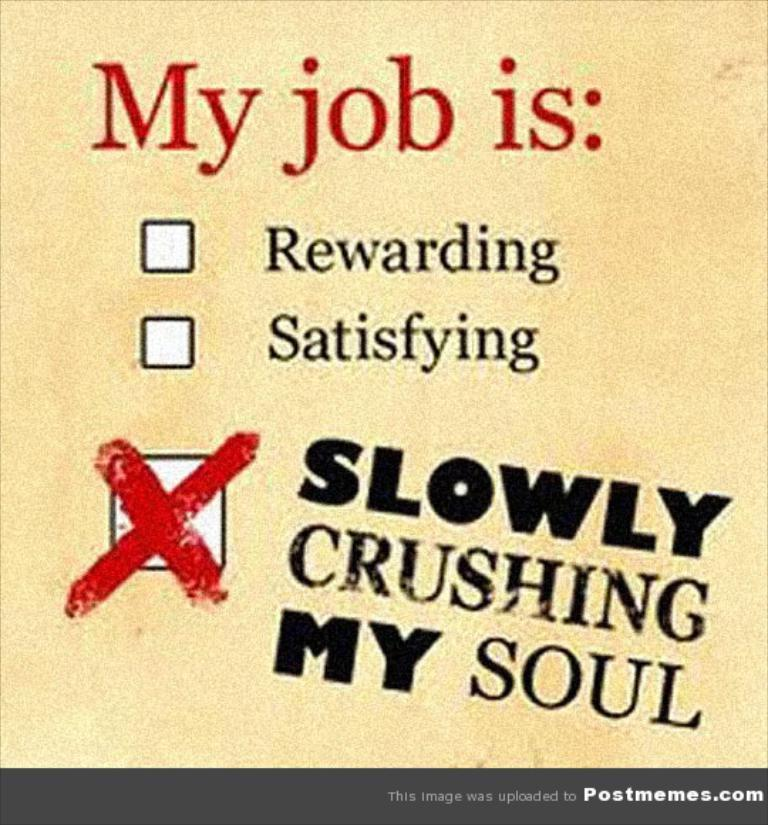<image>
Share a concise interpretation of the image provided. A poster about job satisfaction and one box marked. 